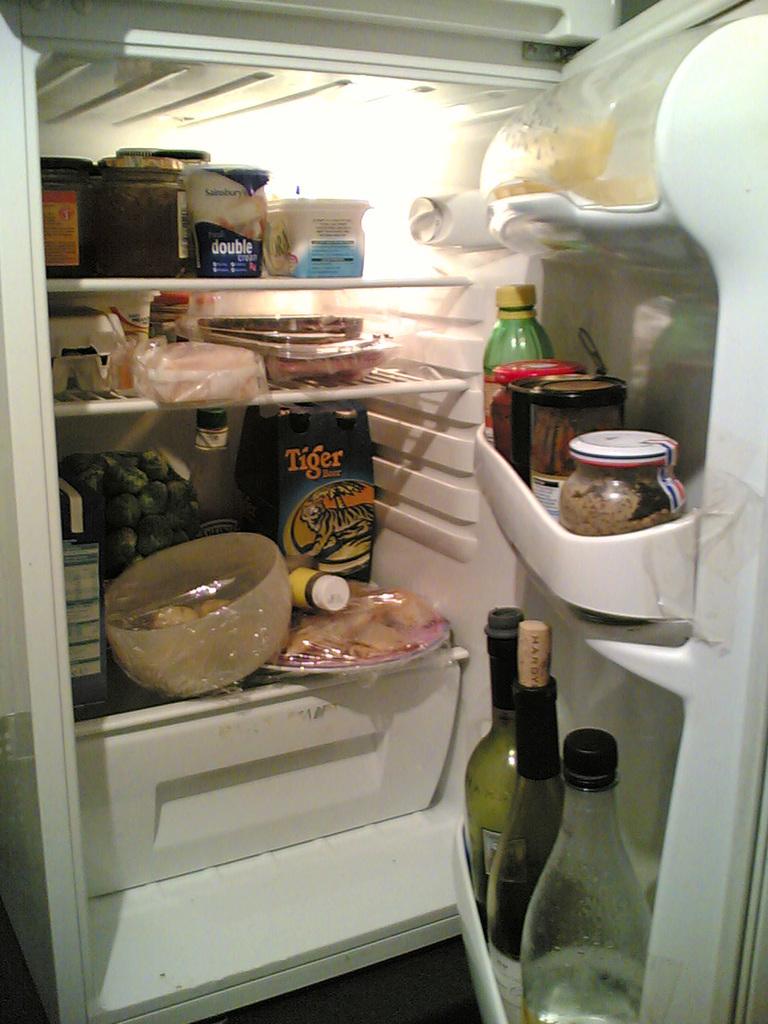What brand of beer is there in the fridge?
Ensure brevity in your answer.  Tiger. What brand is in orange font?
Offer a very short reply. Tiger. 